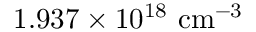Convert formula to latex. <formula><loc_0><loc_0><loc_500><loc_500>1 . 9 3 7 \times 1 0 ^ { 1 8 } \ c m ^ { - 3 }</formula> 